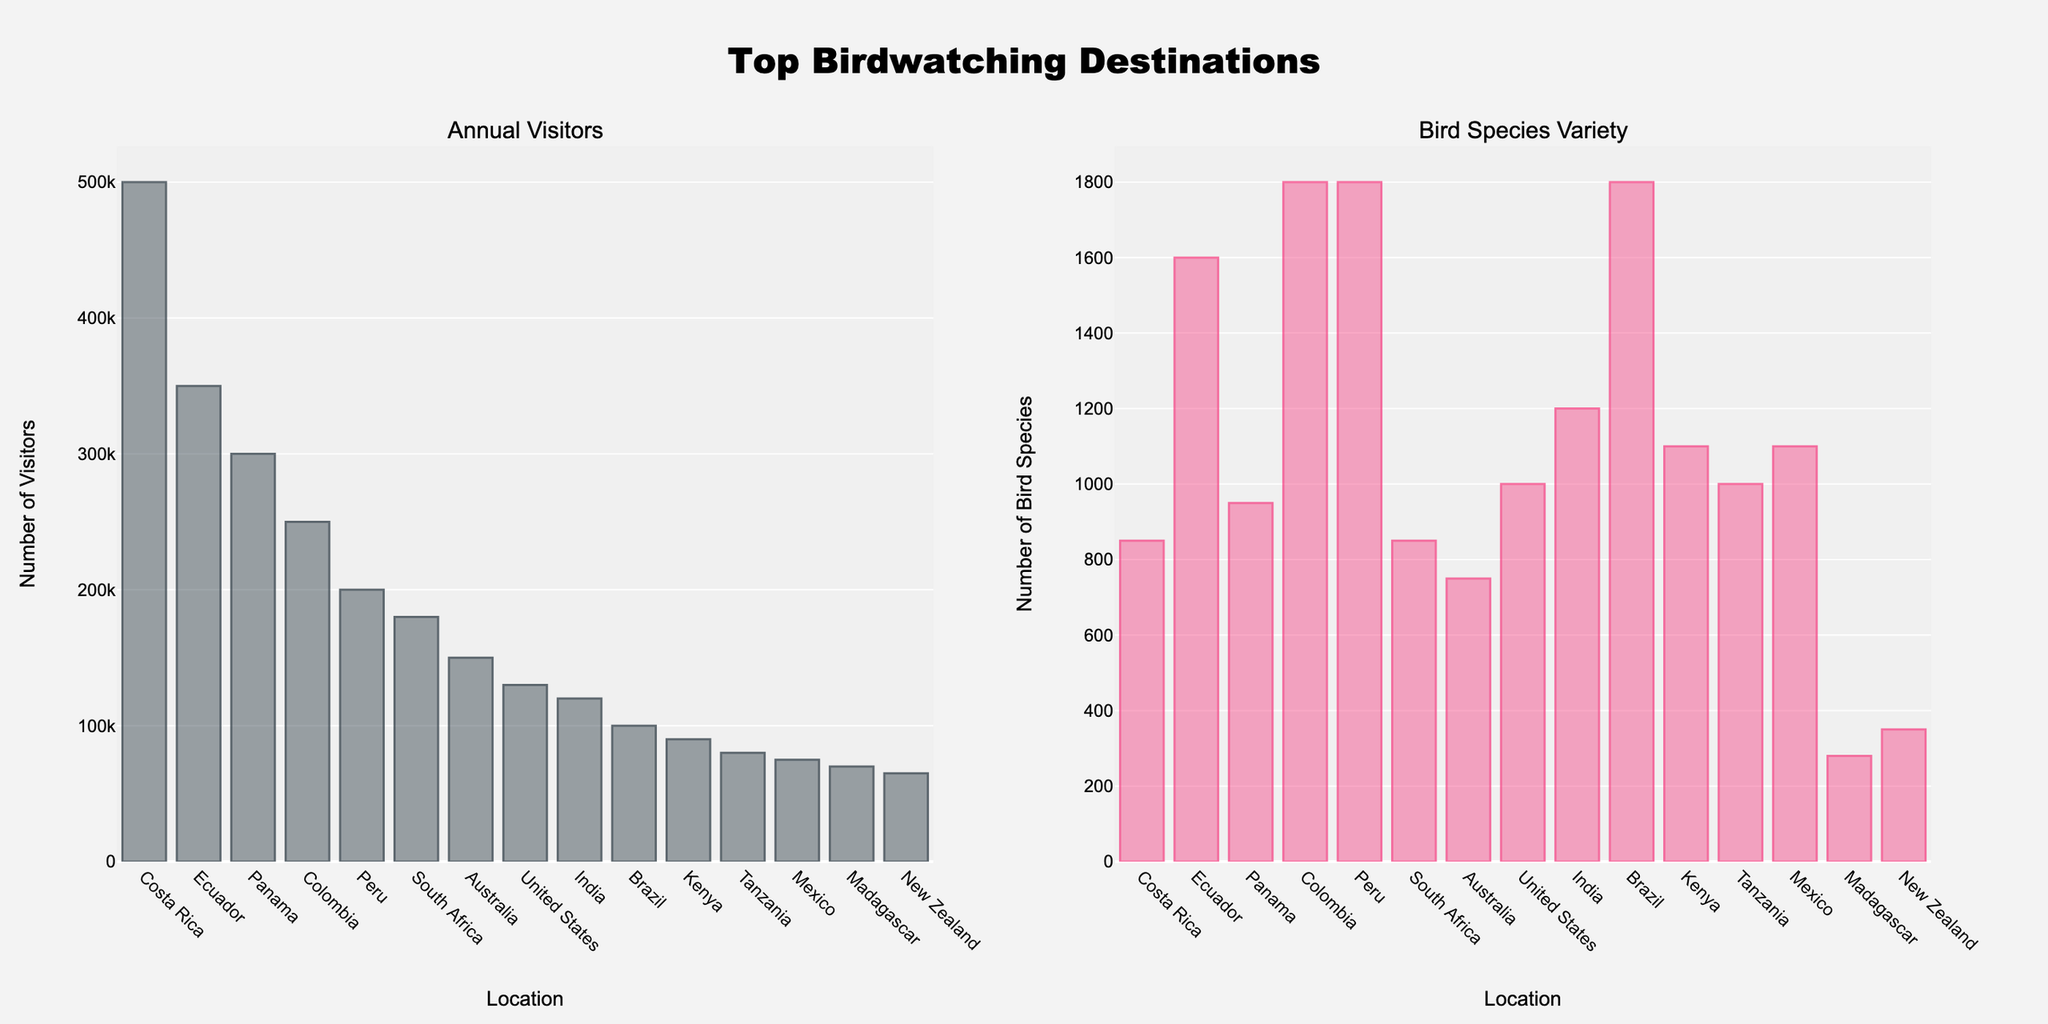Which location has the highest number of annual visitors? The height of the bar for annual visitors is highest for Costa Rica, which indicates it has the highest number of annual visitors.
Answer: Costa Rica Which location has the highest bird species variety? The tallest bar for bird species variety is for Peru, Colombia, and Brazil, indicating these locations have the highest bird species variety.
Answer: Colombia, Peru, Brazil How many more visitors does Costa Rica have compared to the United States? Refer to the bars representing Costa Rica and the United States. Costa Rica's bar for annual visitors is at 500,000 and the United States is at 130,000. The difference is 500,000 - 130,000.
Answer: 370,000 Which location has the lowest bird species variety? The shortest bar in the bird species variety subplot represents Madagascar, indicating it has the lowest bird species variety.
Answer: Madagascar What is the combined number of bird species varieties for Colombia, Ecuador, and Panama? Look at the bars for bird species variety for Colombia (1800), Ecuador (1600), and Panama (950). The sum is 1800 + 1600 + 950.
Answer: 4350 How does the number of annual visitors in Kenya compare to those in New Zealand? Compare the bars for annual visitors. Kenya's bar reaches 90,000 and New Zealand’s bar reaches 65,000. Kenya has more visitors than New Zealand.
Answer: Kenya has more If you combine the number of visitors from Ecuador and Panama, how does it compare to Costa Rica’s total? The bars show Ecuador with 350,000 visitors and Panama with 300,000. Their combined total is 350,000 + 300,000 which should be compared to Costa Rica's 500,000 visitors.
Answer: Ecuador and Panama combined have more Which location has both a high number of species variety and a moderate number of annual visitors? Identify a location with a high bird species variety bar and a moderate annual visitor bar. Colombia has high species variety (1800) and moderate annual visitors (250,000).
Answer: Colombia Which two locations have exactly the same bird species variety? Look for locations with bars of equal height in the bird species variety subplot. Peru, Colombia, and Brazil all have bars representing 1800 bird species.
Answer: Peru, Colombia, Brazil What is the average number of bird species variety in South Africa, Australia, and India? The bird species variety for South Africa is 850, Australia is 750, and India is 1200. The sum is 850 + 750 + 1200, and the average is (850 + 750 + 1200) / 3.
Answer: 933.33 